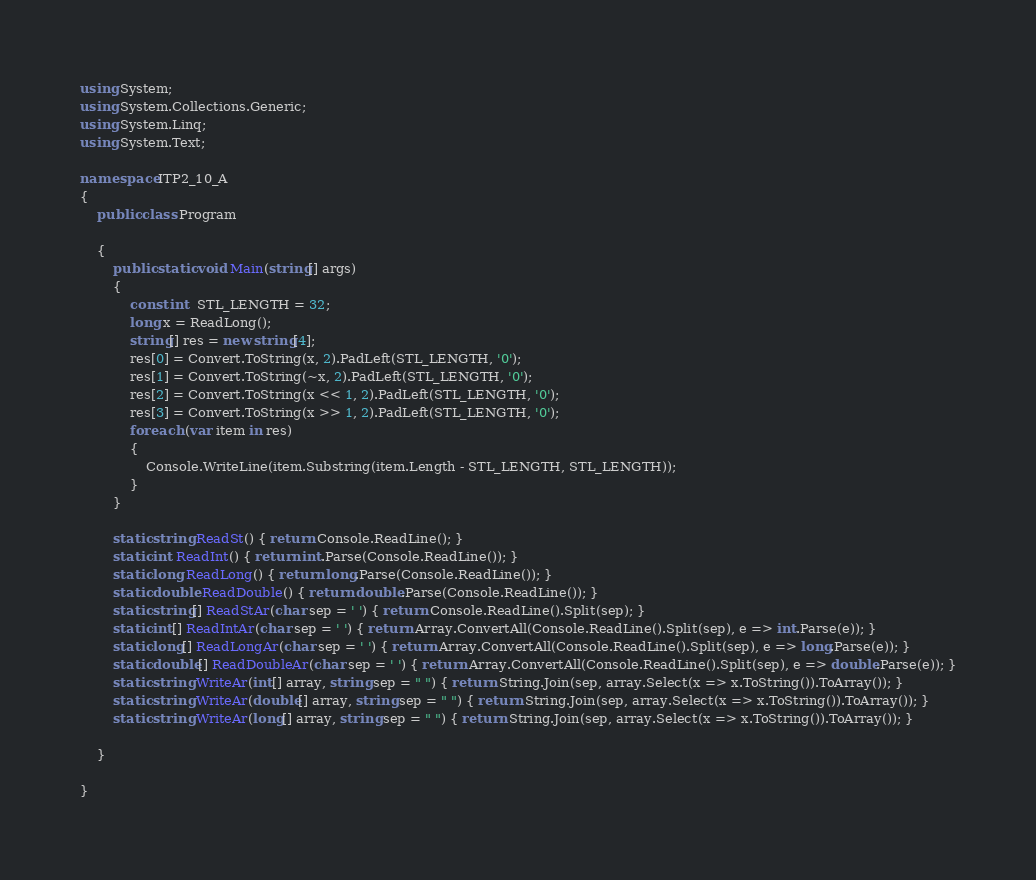<code> <loc_0><loc_0><loc_500><loc_500><_C#_>using System;
using System.Collections.Generic;
using System.Linq;
using System.Text;

namespace ITP2_10_A
{
    public class Program

    {
        public static void Main(string[] args)
        {
            const int  STL_LENGTH = 32;
            long x = ReadLong();
            string[] res = new string[4];
            res[0] = Convert.ToString(x, 2).PadLeft(STL_LENGTH, '0');
            res[1] = Convert.ToString(~x, 2).PadLeft(STL_LENGTH, '0');
            res[2] = Convert.ToString(x << 1, 2).PadLeft(STL_LENGTH, '0');
            res[3] = Convert.ToString(x >> 1, 2).PadLeft(STL_LENGTH, '0');
            foreach (var item in res)
            {
                Console.WriteLine(item.Substring(item.Length - STL_LENGTH, STL_LENGTH));
            }
        }

        static string ReadSt() { return Console.ReadLine(); }
        static int ReadInt() { return int.Parse(Console.ReadLine()); }
        static long ReadLong() { return long.Parse(Console.ReadLine()); }
        static double ReadDouble() { return double.Parse(Console.ReadLine()); }
        static string[] ReadStAr(char sep = ' ') { return Console.ReadLine().Split(sep); }
        static int[] ReadIntAr(char sep = ' ') { return Array.ConvertAll(Console.ReadLine().Split(sep), e => int.Parse(e)); }
        static long[] ReadLongAr(char sep = ' ') { return Array.ConvertAll(Console.ReadLine().Split(sep), e => long.Parse(e)); }
        static double[] ReadDoubleAr(char sep = ' ') { return Array.ConvertAll(Console.ReadLine().Split(sep), e => double.Parse(e)); }
        static string WriteAr(int[] array, string sep = " ") { return String.Join(sep, array.Select(x => x.ToString()).ToArray()); }
        static string WriteAr(double[] array, string sep = " ") { return String.Join(sep, array.Select(x => x.ToString()).ToArray()); }
        static string WriteAr(long[] array, string sep = " ") { return String.Join(sep, array.Select(x => x.ToString()).ToArray()); }

    }

}

</code> 